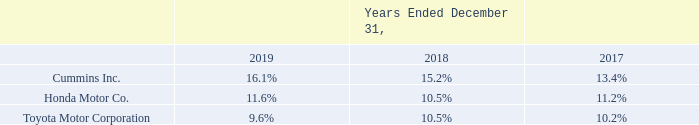Our net sales to significant customers as a percentage of total net sales were as follows:
We sell parts to these three transportation customers for certain vehicle platforms under purchase agreements that have no volume commitments and are subject to purchase orders issued from time to time.
No other customer accounted for 10% or more of total net sales during these periods. We continue to focus on broadening our customer base to diversify our end market exposure.
Changes in the level of our customers' orders have, in the past, had a significant impact on our operating results. If a major customer reduces the amount of business it does with us, or substantially changes the terms of that business, there could be an adverse impact on our operating results
Which years does the table provide information for the company's net sales to significant customers as a percentage of total net sales? 2019, 2018, 2017. What was the percentage of total net sales occupied by Cummins Inc. in 2017?
Answer scale should be: percent. 13.4. What was the percentage of total net sales occupied by Honda Motor Co. in 2019?
Answer scale should be: percent. 11.6. How many years did Cummins Inc. occupy more than 15% of the company's total net sales? 2019##2018
Answer: 2. What was the change in the percentage of total net sales from Honda Motor Co. between 2017 and 2018?
Answer scale should be: percent. 10.5-11.2
Answer: -0.7. What was the sum of the percentages of total net sales between Honda Motor Co. and Toyota Motor Corporation in 2017?
Answer scale should be: percent. 11.2+10.2
Answer: 21.4. 